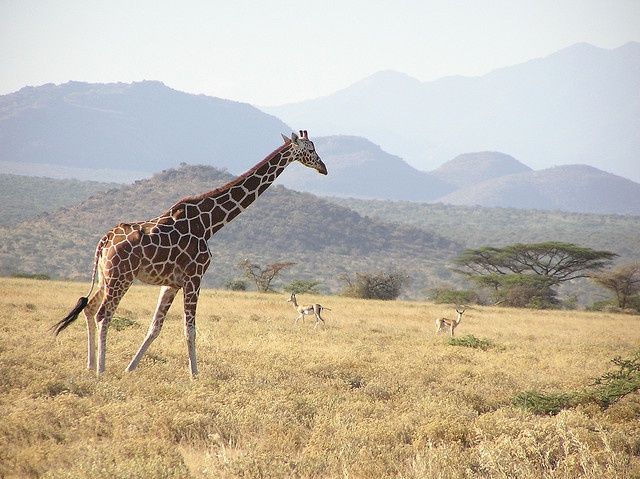Describe the objects in this image and their specific colors. I can see a giraffe in lightgray, black, maroon, and gray tones in this image. 